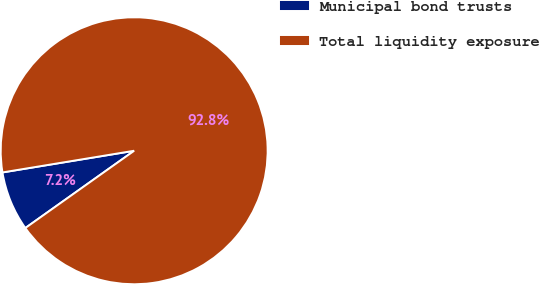Convert chart to OTSL. <chart><loc_0><loc_0><loc_500><loc_500><pie_chart><fcel>Municipal bond trusts<fcel>Total liquidity exposure<nl><fcel>7.23%<fcel>92.77%<nl></chart> 